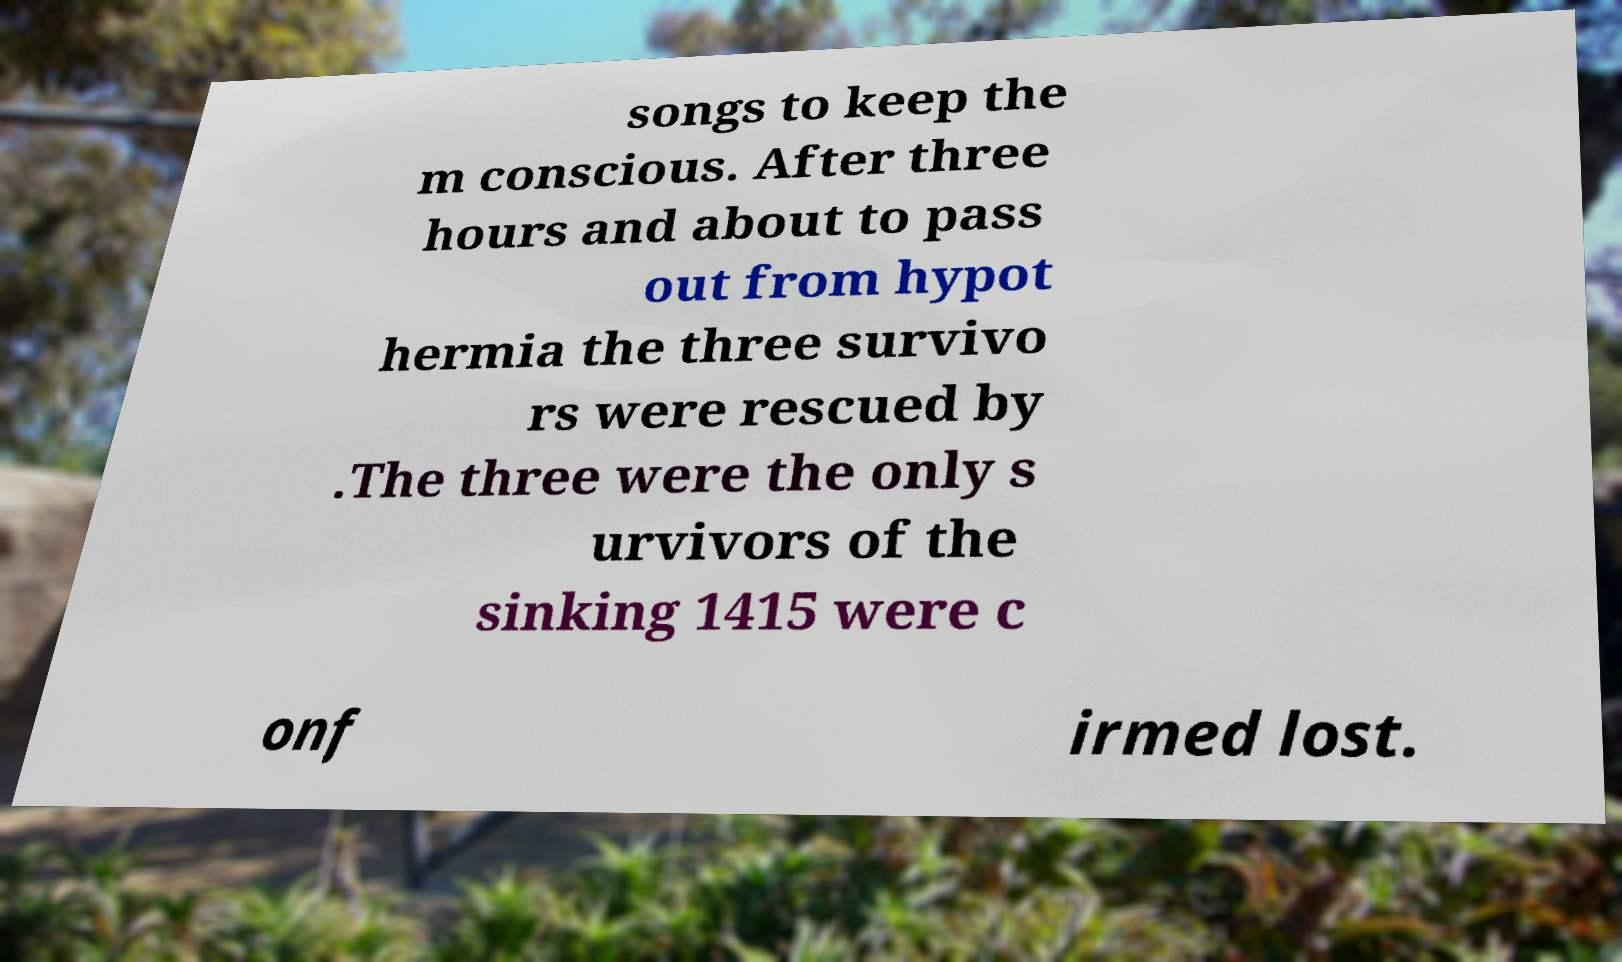There's text embedded in this image that I need extracted. Can you transcribe it verbatim? songs to keep the m conscious. After three hours and about to pass out from hypot hermia the three survivo rs were rescued by .The three were the only s urvivors of the sinking 1415 were c onf irmed lost. 